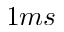Convert formula to latex. <formula><loc_0><loc_0><loc_500><loc_500>1 m s</formula> 